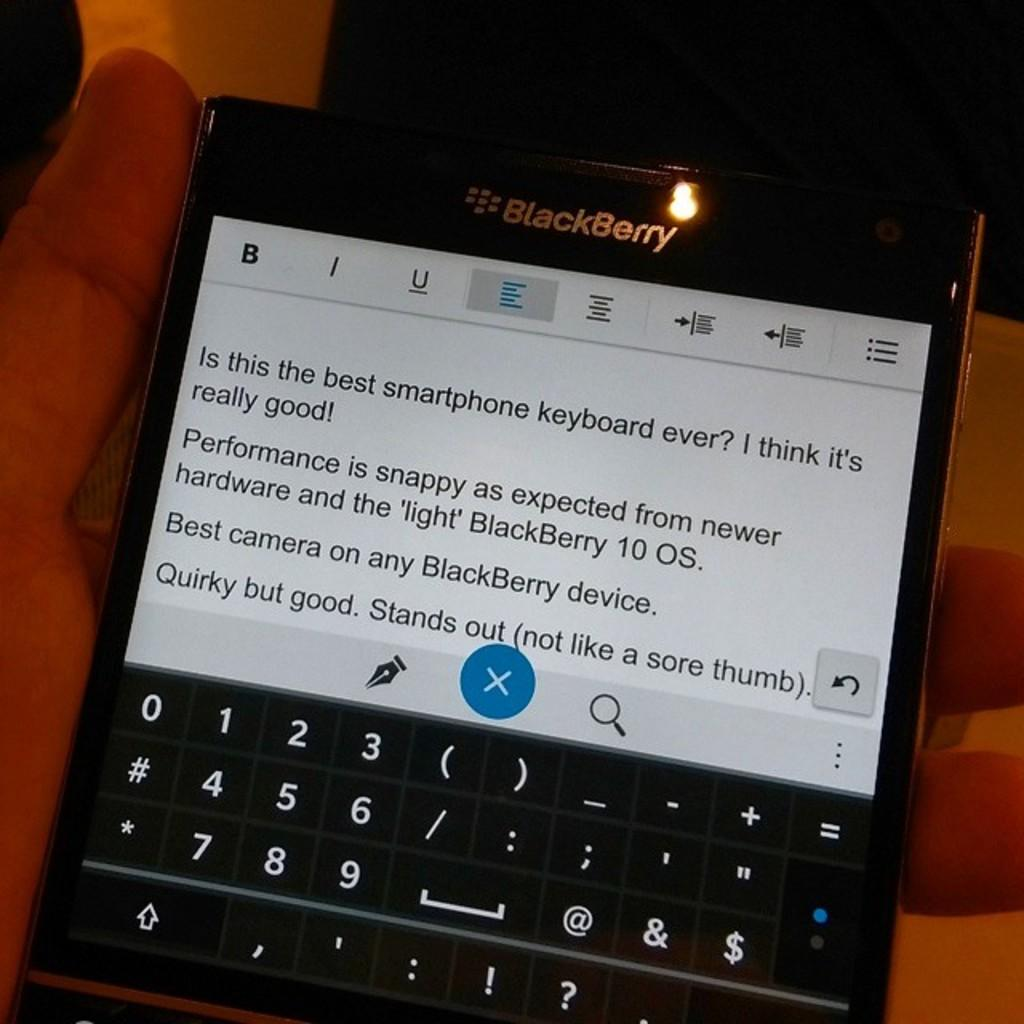<image>
Create a compact narrative representing the image presented. BlackBerry cell phone with text stating "Is this the best smartphone keyboard every? I think it's really good!" on the screen. 